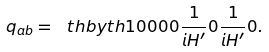Convert formula to latex. <formula><loc_0><loc_0><loc_500><loc_500>q _ { a b } = \ t h b y t h { 1 } { 0 } { 0 } { 0 } { 0 } { \frac { 1 } { i H ^ { \prime } } } { 0 } { \frac { 1 } { i H ^ { \prime } } } { 0 } .</formula> 